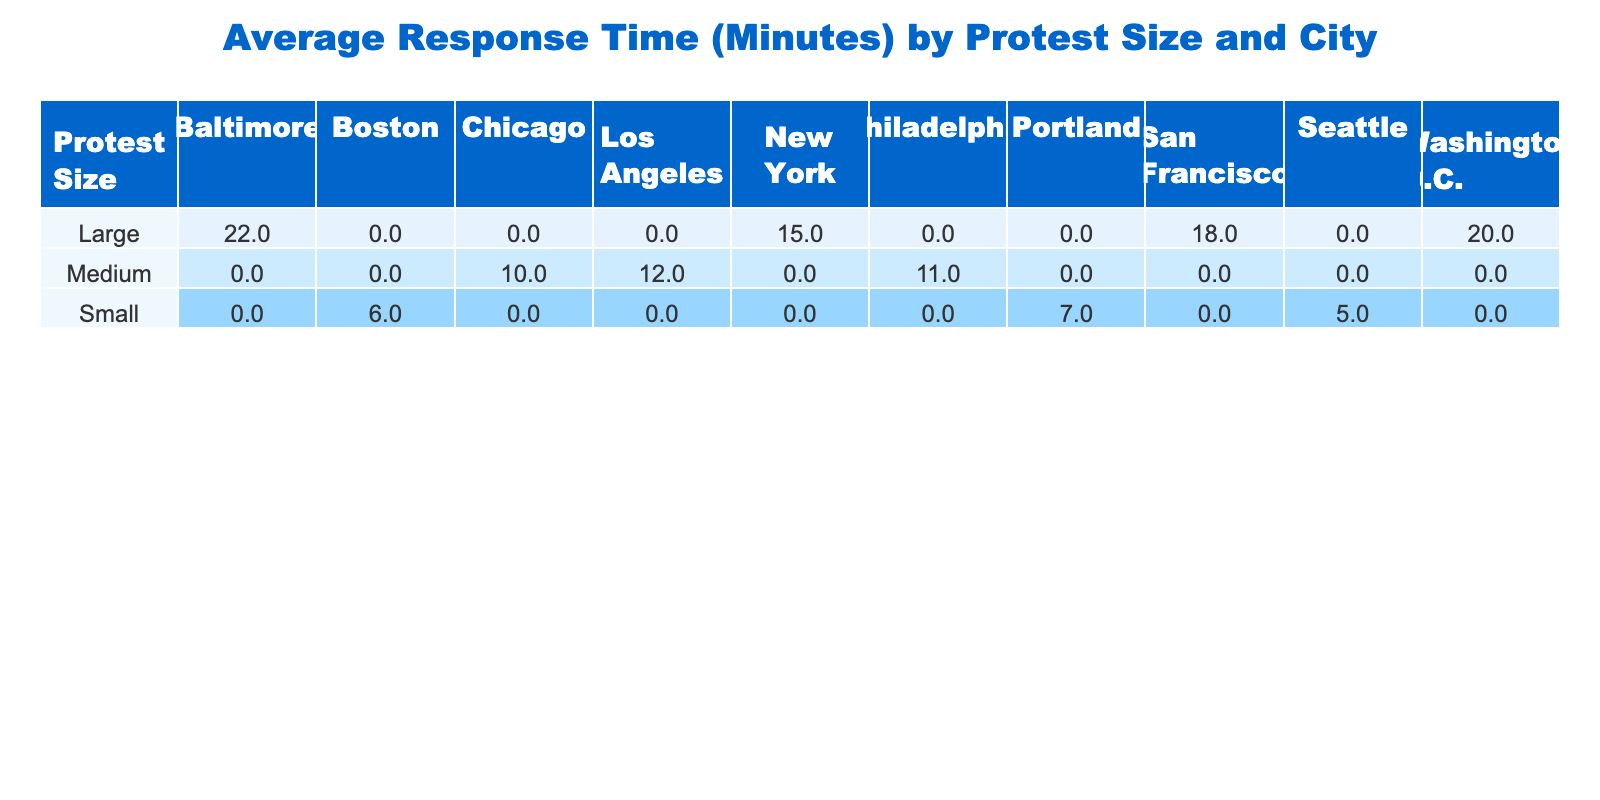What is the average response time for small protests in Seattle? The table indicates that the response time for a small protest in Seattle is 5 minutes.
Answer: 5 Which city had the longest average response time for medium protests? The table lists medium protests response times as follows: Chicago (10 minutes), Los Angeles (12 minutes), and Philadelphia (11 minutes). The highest value is in Los Angeles at 12 minutes.
Answer: Los Angeles True or False: The average response time for large protests in New York is less than that of large protests in Washington D.C. The average response time for the large protest in New York is 15 minutes, while in Washington D.C., it is 20 minutes. Since 15 is not less than 20, the statement is false.
Answer: False What is the difference in average response times between medium protests and large protests in San Francisco? The average response time for the medium protests (as a comparison, note we only have one value for large protests) in San Francisco is not given, but looking at the overall data, large protests in San Francisco are 18 minutes. Medium protests in San Francisco are not present in the data, hence the difference cannot be determined.
Answer: Cannot determine What is the total average response time across all protest sizes in Boston? The response time for the small protest in Boston is 6 minutes. There are no medium or large protests in Boston according to the table. Therefore, the total average response time for Boston is just from the small protest, which is 6 minutes.
Answer: 6 What is the average of average response times for large protests across all cities? The average response times for large protests in the cities are as follows: New York (15 minutes), San Francisco (18 minutes), and Baltimore (22 minutes). The sum is 15 + 18 + 22 = 55 minutes. There are 3 data points, so the average response time is 55/3 = 18.33 minutes.
Answer: 18.3 Which city had the fastest response time among small protests? From the table, the small protests response times are: Seattle (5 minutes), Portland (7 minutes), and Boston (6 minutes). The fastest time is shown in Seattle at 5 minutes.
Answer: Seattle True or False: The average response time for medium-sized protests in Philadelphia is higher than that in Chicago. The average response times are Chicago (10 minutes), Philadelphia (11 minutes). Since 11 is greater than 10, the statement is true.
Answer: True 